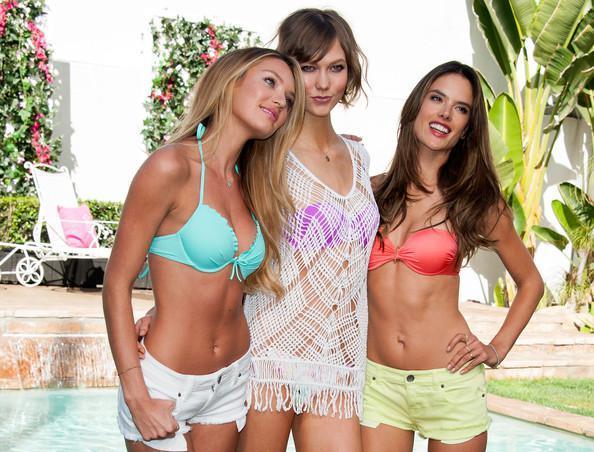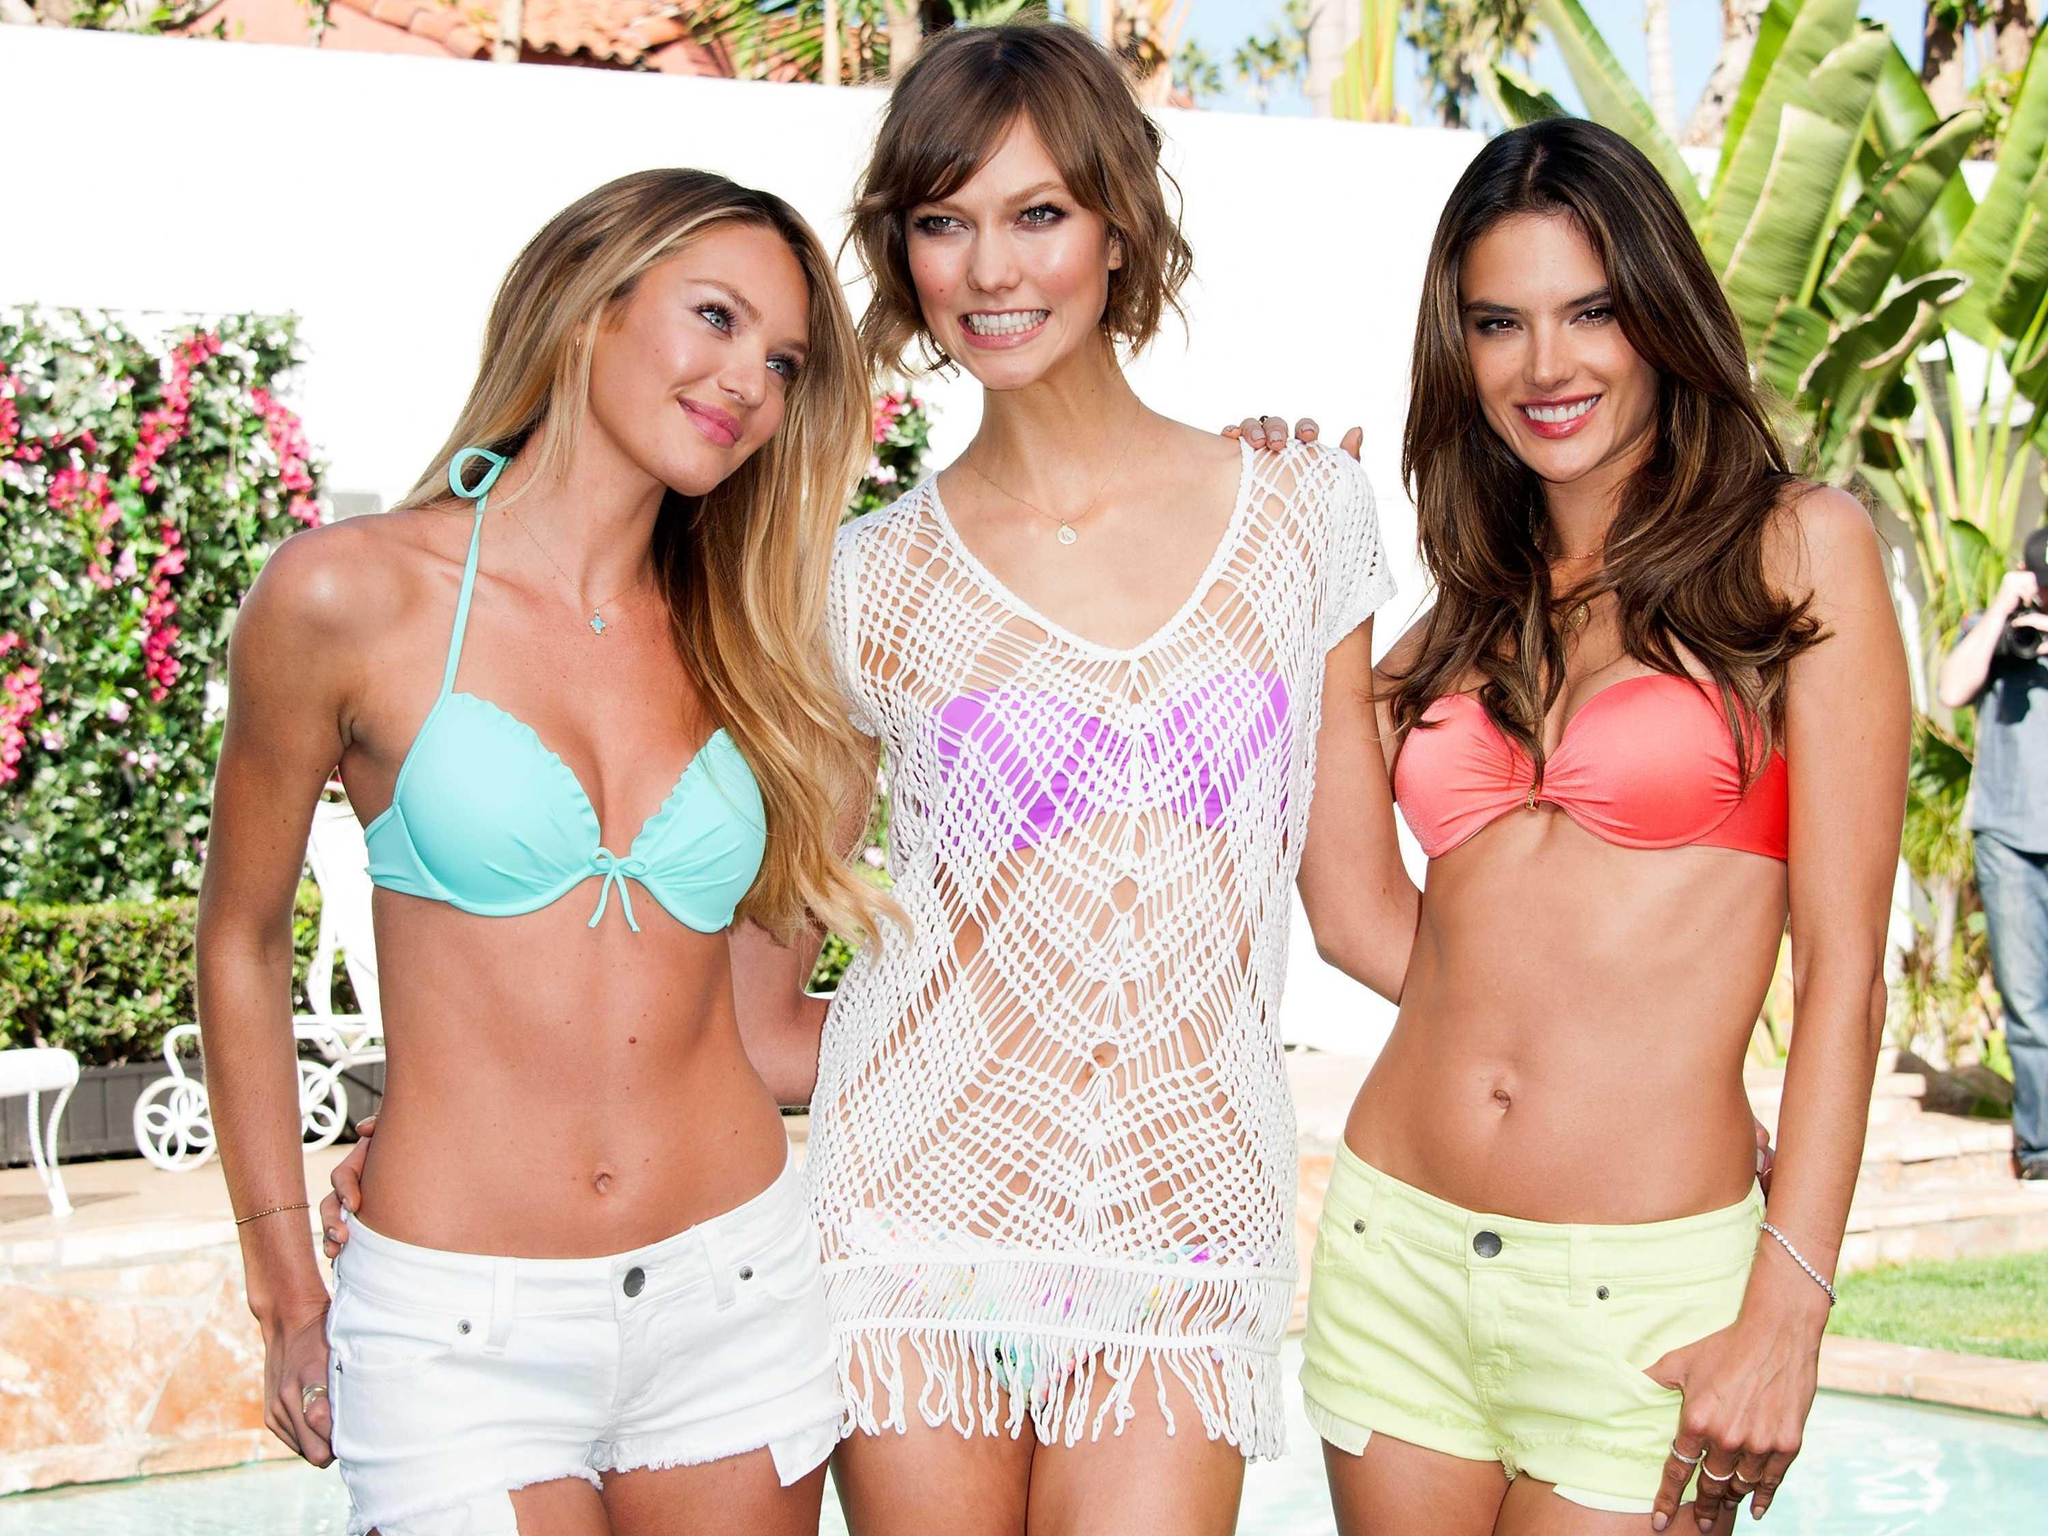The first image is the image on the left, the second image is the image on the right. Analyze the images presented: Is the assertion "Each of the images contains exactly one model." valid? Answer yes or no. No. 